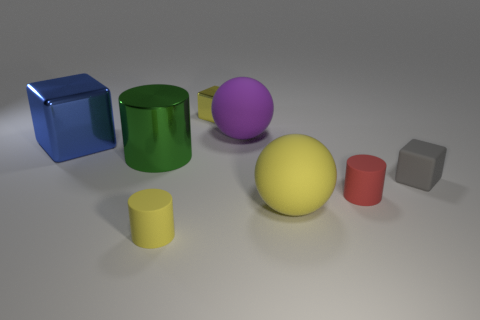There is a purple rubber thing; what number of small rubber cylinders are to the right of it?
Ensure brevity in your answer.  1. Is the shape of the metal object behind the large blue metallic object the same as  the large blue metal thing?
Provide a succinct answer. Yes. What color is the rubber cylinder that is to the right of the purple sphere?
Your answer should be very brief. Red. There is a large purple object that is the same material as the tiny gray thing; what shape is it?
Your answer should be compact. Sphere. Is there anything else that is the same color as the big metal cylinder?
Keep it short and to the point. No. Are there more yellow matte objects that are to the left of the small red rubber thing than tiny matte blocks to the right of the gray matte thing?
Offer a very short reply. Yes. What number of blue matte cubes are the same size as the green thing?
Offer a very short reply. 0. Are there fewer small yellow rubber objects on the left side of the yellow matte cylinder than yellow metal objects that are on the right side of the large metal cube?
Your answer should be compact. Yes. Is there a small red object that has the same shape as the green object?
Provide a succinct answer. Yes. Does the purple matte thing have the same shape as the big yellow object?
Keep it short and to the point. Yes. 